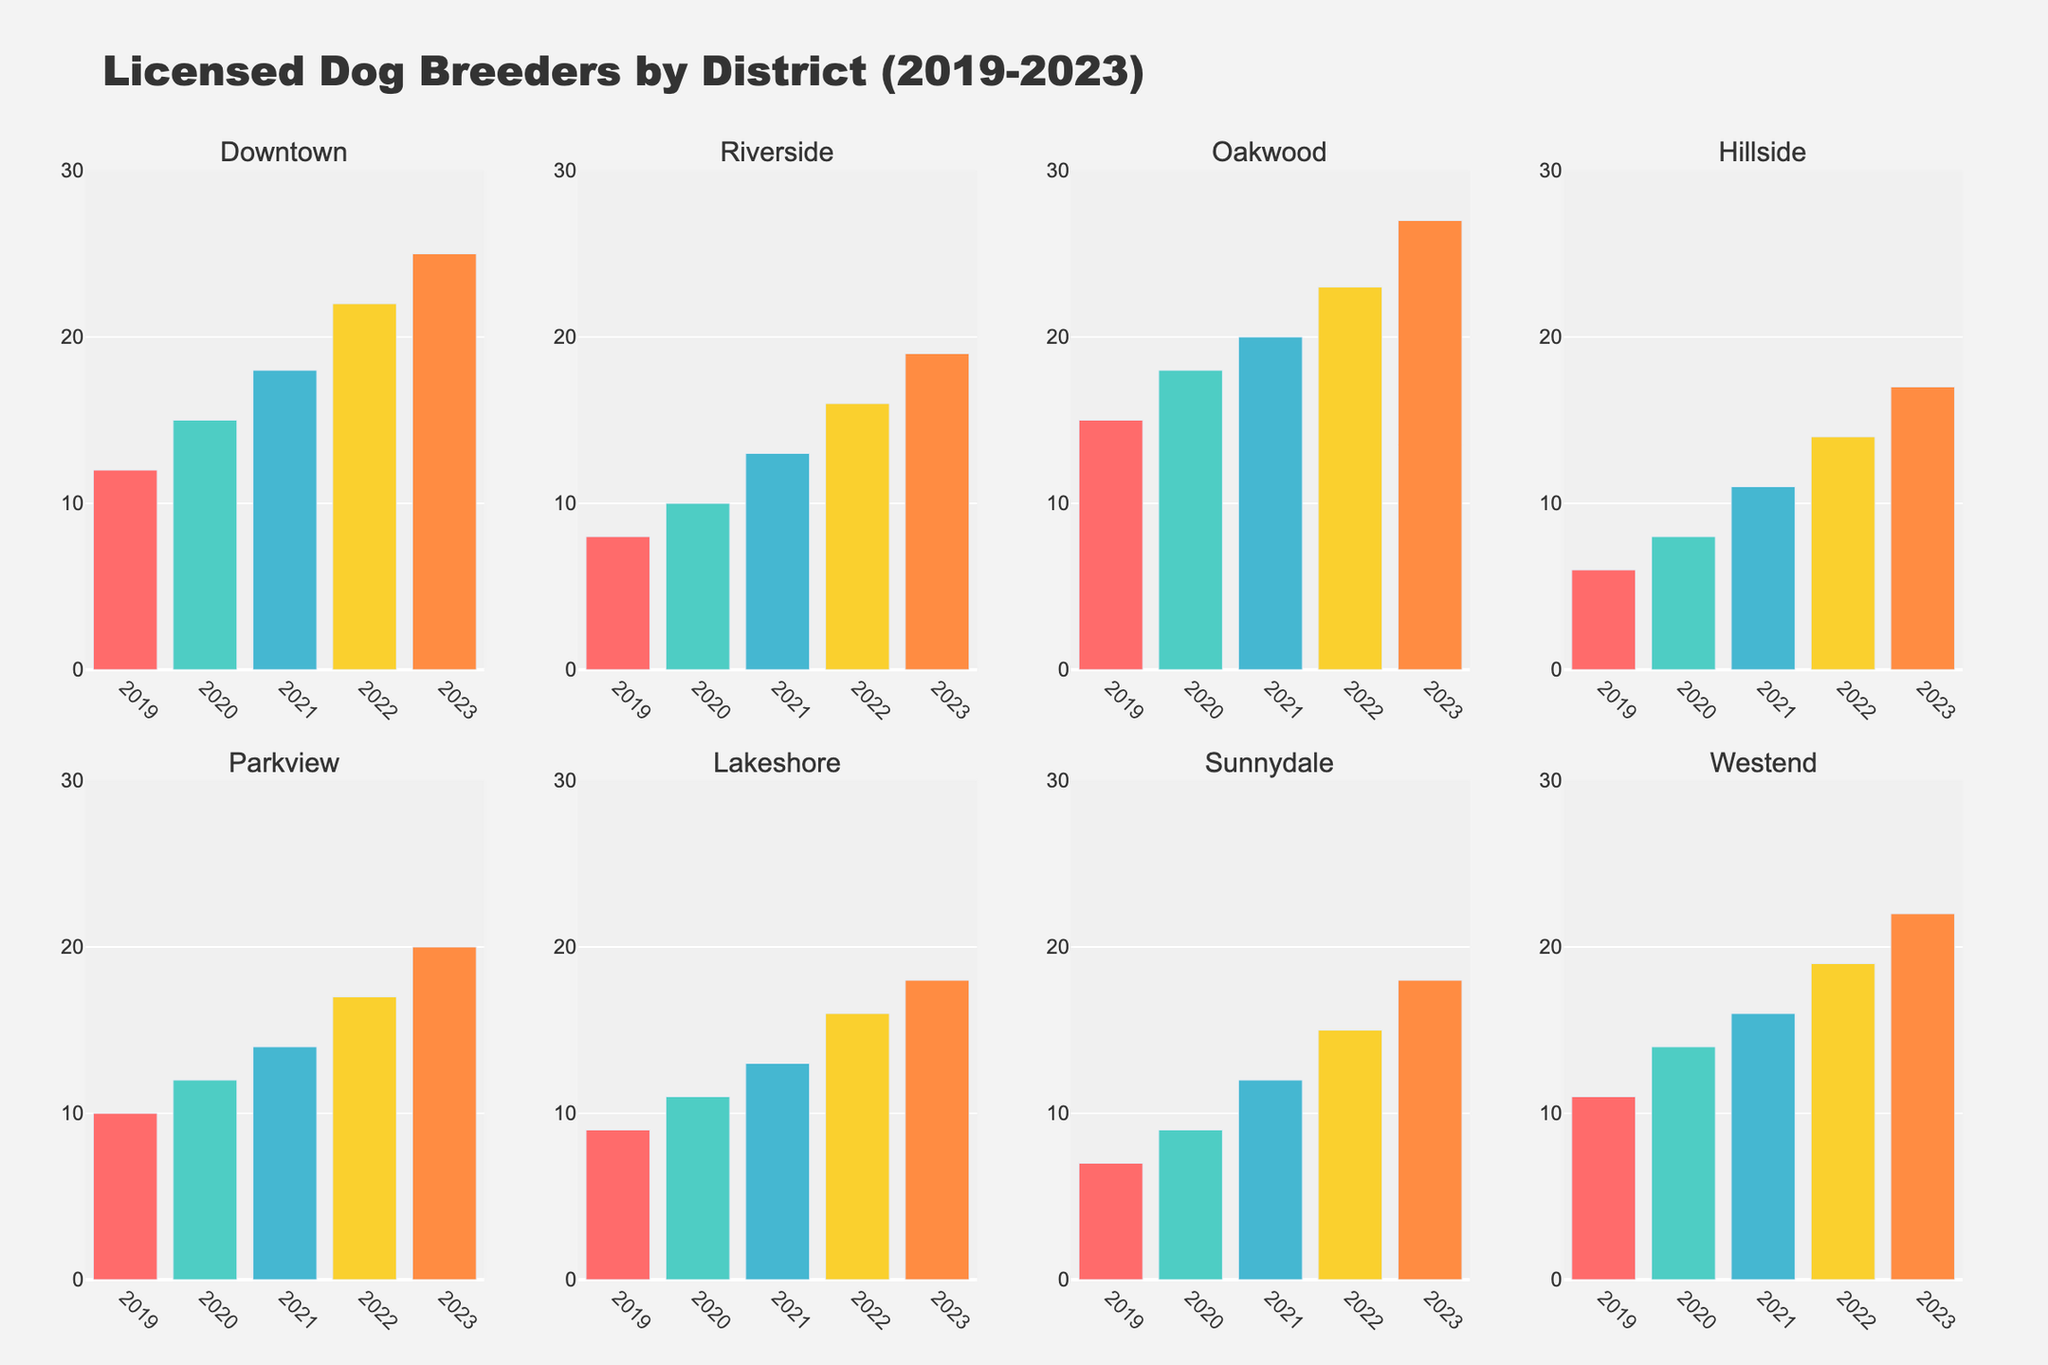what is the title of the figure? The title is usually placed at the top of the figure. In this case, it is mentioned at the top center.
Answer: Licensed Dog Breeders by District (2019-2023) Which district had the most licensed dog breeders in 2023? By examining the height of the bars in 2023 for each subplot, we can determine that Oakwood had the highest number of breeders in 2023.
Answer: Oakwood How many licensed dog breeders were there in Parkview in 2021? Find the bar corresponding to the year 2021 in the Parkview subplot and read its height.
Answer: 14 What is the difference in the number of licensed dog breeders between Downtown and Riverside in 2023? Find the values for 2023 in Downtown and Riverside, which are 25 and 19 respectively, and subtract the smaller number from the larger one.
Answer: 6 Which year shows the most significant increase in licensed dog breeders for the Westend district? Examine the differences between consecutive years in the Westend subplot. The largest increase is between 2021 (16) and 2022 (19).
Answer: 2022 Which district had the least number of licensed dog breeders in 2019? By comparing the heights of the bars for 2019 across all subplots, we see that Hillside had the lowest number of breeders in 2019.
Answer: Hillside On average, how many licensed dog breeders were there in Riverside from 2019 to 2023? Sum the values for Riverside from 2019 to 2023 (8, 10, 13, 16, 19) which totals 66, then divide by the number of years, which is 5.
Answer: 13.2 Which districts had exactly 18 licensed dog breeders in 2023? Check all the bar heights corresponding to the year 2023 across the subplots. Both Lakeshore and Sunnydale had 18 breeders each in that year.
Answer: Lakeshore, Sunnydale In which district did the number of licensed dog breeders stay below 20 for every year from 2019 to 2023? Examine each subplot and look for districts where no bar exceeds the value of 20 within the years 2019 to 2023. Hillside meets this criterion.
Answer: Hillside Which district had the highest increase in the number of licensed dog breeders from 2019 to 2023? Calculate the differences between the numbers in 2023 and 2019 for each district and identify the district with the largest difference. Oakwood increased from 15 to 27, a difference of 12, which is the highest.
Answer: Oakwood 